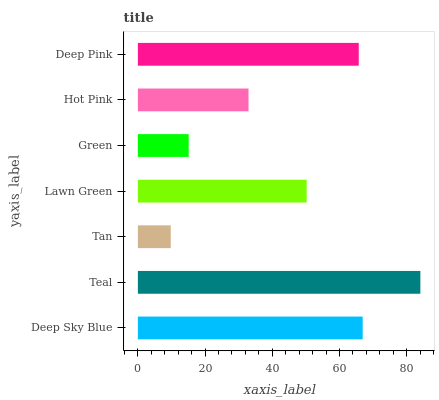Is Tan the minimum?
Answer yes or no. Yes. Is Teal the maximum?
Answer yes or no. Yes. Is Teal the minimum?
Answer yes or no. No. Is Tan the maximum?
Answer yes or no. No. Is Teal greater than Tan?
Answer yes or no. Yes. Is Tan less than Teal?
Answer yes or no. Yes. Is Tan greater than Teal?
Answer yes or no. No. Is Teal less than Tan?
Answer yes or no. No. Is Lawn Green the high median?
Answer yes or no. Yes. Is Lawn Green the low median?
Answer yes or no. Yes. Is Tan the high median?
Answer yes or no. No. Is Tan the low median?
Answer yes or no. No. 